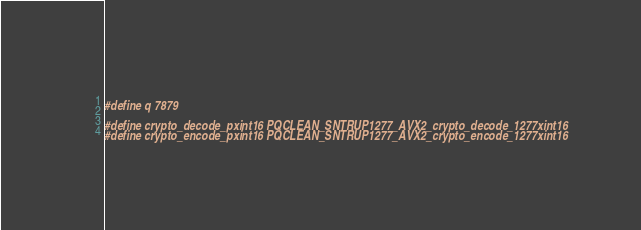<code> <loc_0><loc_0><loc_500><loc_500><_C_>#define q 7879

#define crypto_decode_pxint16 PQCLEAN_SNTRUP1277_AVX2_crypto_decode_1277xint16
#define crypto_encode_pxint16 PQCLEAN_SNTRUP1277_AVX2_crypto_encode_1277xint16
</code> 